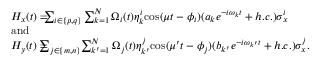<formula> <loc_0><loc_0><loc_500><loc_500>\begin{array} { r l } & { H _ { x } ( t ) = \, \sum _ { i \in \{ p , q \} } \sum _ { k = 1 } ^ { N } \Omega _ { i } ( t ) \eta _ { k } ^ { i } \cos ( \mu t - \phi _ { i } ) ( a _ { k } e ^ { - i \omega _ { k } t } + h . c . ) \sigma _ { x } ^ { i } } \\ & { a n d } \\ & { H _ { y } ( t ) = \, \sum _ { j \in \{ m , n \} } \, \sum _ { k ^ { \prime } = 1 } ^ { N } \Omega _ { j } ( t ) \eta _ { k ^ { \prime } } ^ { j } \cos ( \mu ^ { \prime } t - \phi _ { j } ) ( b _ { k ^ { \prime } } e ^ { - i \omega _ { k ^ { \prime } } t } + h . c . ) \sigma _ { x } ^ { j } . } \end{array}</formula> 